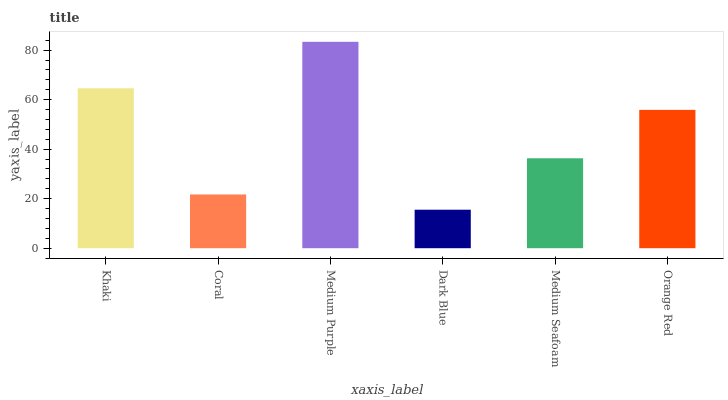Is Dark Blue the minimum?
Answer yes or no. Yes. Is Medium Purple the maximum?
Answer yes or no. Yes. Is Coral the minimum?
Answer yes or no. No. Is Coral the maximum?
Answer yes or no. No. Is Khaki greater than Coral?
Answer yes or no. Yes. Is Coral less than Khaki?
Answer yes or no. Yes. Is Coral greater than Khaki?
Answer yes or no. No. Is Khaki less than Coral?
Answer yes or no. No. Is Orange Red the high median?
Answer yes or no. Yes. Is Medium Seafoam the low median?
Answer yes or no. Yes. Is Coral the high median?
Answer yes or no. No. Is Khaki the low median?
Answer yes or no. No. 